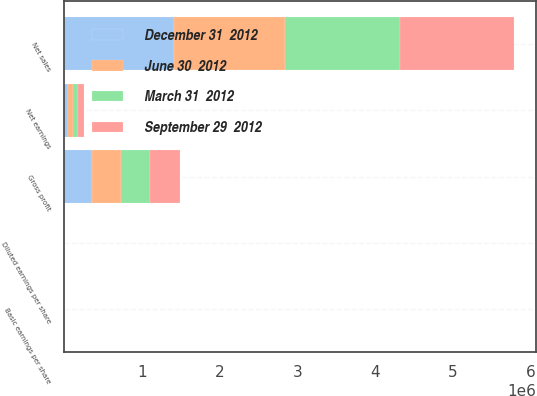Convert chart to OTSL. <chart><loc_0><loc_0><loc_500><loc_500><stacked_bar_chart><ecel><fcel>Net sales<fcel>Gross profit<fcel>Net earnings<fcel>Basic earnings per share<fcel>Diluted earnings per share<nl><fcel>December 31  2012<fcel>1.40904e+06<fcel>359426<fcel>40377<fcel>0.59<fcel>0.58<nl><fcel>September 29  2012<fcel>1.46979e+06<fcel>388464<fcel>73188<fcel>1.06<fcel>1.06<nl><fcel>March 31  2012<fcel>1.47349e+06<fcel>372837<fcel>70304<fcel>1.02<fcel>1.01<nl><fcel>June 30  2012<fcel>1.43566e+06<fcel>369331<fcel>66389<fcel>0.96<fcel>0.96<nl></chart> 